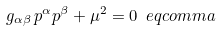Convert formula to latex. <formula><loc_0><loc_0><loc_500><loc_500>g _ { \alpha \beta } \, p ^ { \alpha } p ^ { \beta } + \mu ^ { 2 } = 0 \ e q c o m m a</formula> 